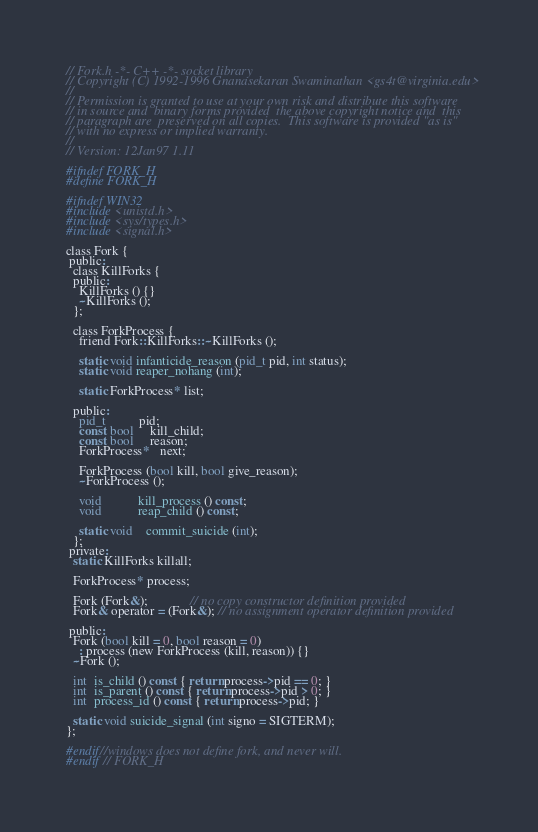<code> <loc_0><loc_0><loc_500><loc_500><_C_>// Fork.h -*- C++ -*- socket library
// Copyright (C) 1992-1996 Gnanasekaran Swaminathan <gs4t@virginia.edu>
//
// Permission is granted to use at your own risk and distribute this software
// in source and  binary forms provided  the above copyright notice and  this
// paragraph are  preserved on all copies.  This software is provided "as is"
// with no express or implied warranty.
//
// Version: 12Jan97 1.11

#ifndef FORK_H
#define FORK_H

#ifndef WIN32
#include <unistd.h>
#include <sys/types.h>
#include <signal.h>

class Fork {
 public:
  class KillForks {
  public:
    KillForks () {}
    ~KillForks ();
  };

  class ForkProcess {
    friend Fork::KillForks::~KillForks ();

    static void infanticide_reason (pid_t pid, int status);
    static void reaper_nohang (int);

    static ForkProcess* list;

  public:
    pid_t          pid;
    const bool     kill_child;
    const bool     reason;
    ForkProcess*   next;

    ForkProcess (bool kill, bool give_reason);
    ~ForkProcess ();

    void           kill_process () const;
    void           reap_child () const;

    static void    commit_suicide (int);
  };
 private:
  static KillForks killall;

  ForkProcess* process;

  Fork (Fork&);             // no copy constructor definition provided
  Fork& operator = (Fork&); // no assignment operator definition provided

 public:
  Fork (bool kill = 0, bool reason = 0)
    : process (new ForkProcess (kill, reason)) {}
  ~Fork ();

  int  is_child () const { return process->pid == 0; }
  int  is_parent () const { return process->pid > 0; }
  int  process_id () const { return process->pid; }

  static void suicide_signal (int signo = SIGTERM);
};

#endif//windows does not define fork, and never will.
#endif // FORK_H
</code> 